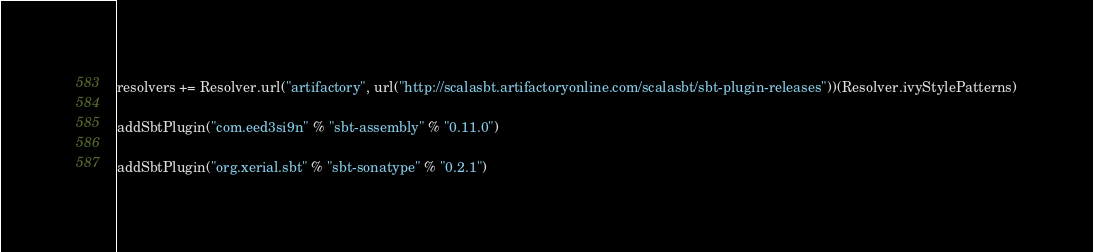Convert code to text. <code><loc_0><loc_0><loc_500><loc_500><_Scala_>resolvers += Resolver.url("artifactory", url("http://scalasbt.artifactoryonline.com/scalasbt/sbt-plugin-releases"))(Resolver.ivyStylePatterns)

addSbtPlugin("com.eed3si9n" % "sbt-assembly" % "0.11.0")

addSbtPlugin("org.xerial.sbt" % "sbt-sonatype" % "0.2.1")



</code> 